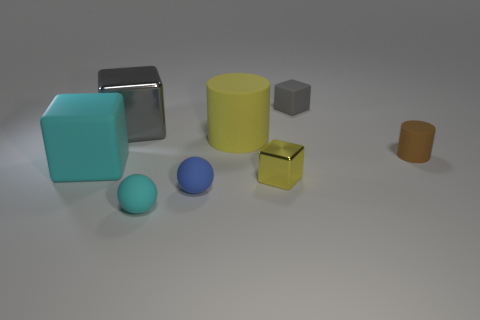Subtract 2 blocks. How many blocks are left? 2 Subtract all yellow cylinders. How many gray cubes are left? 2 Subtract all big cyan matte cubes. How many cubes are left? 3 Add 1 big cyan cubes. How many objects exist? 9 Subtract all cylinders. How many objects are left? 6 Subtract all green blocks. Subtract all cyan cylinders. How many blocks are left? 4 Subtract all big matte blocks. Subtract all matte objects. How many objects are left? 1 Add 5 big metallic blocks. How many big metallic blocks are left? 6 Add 6 shiny things. How many shiny things exist? 8 Subtract 0 blue cubes. How many objects are left? 8 